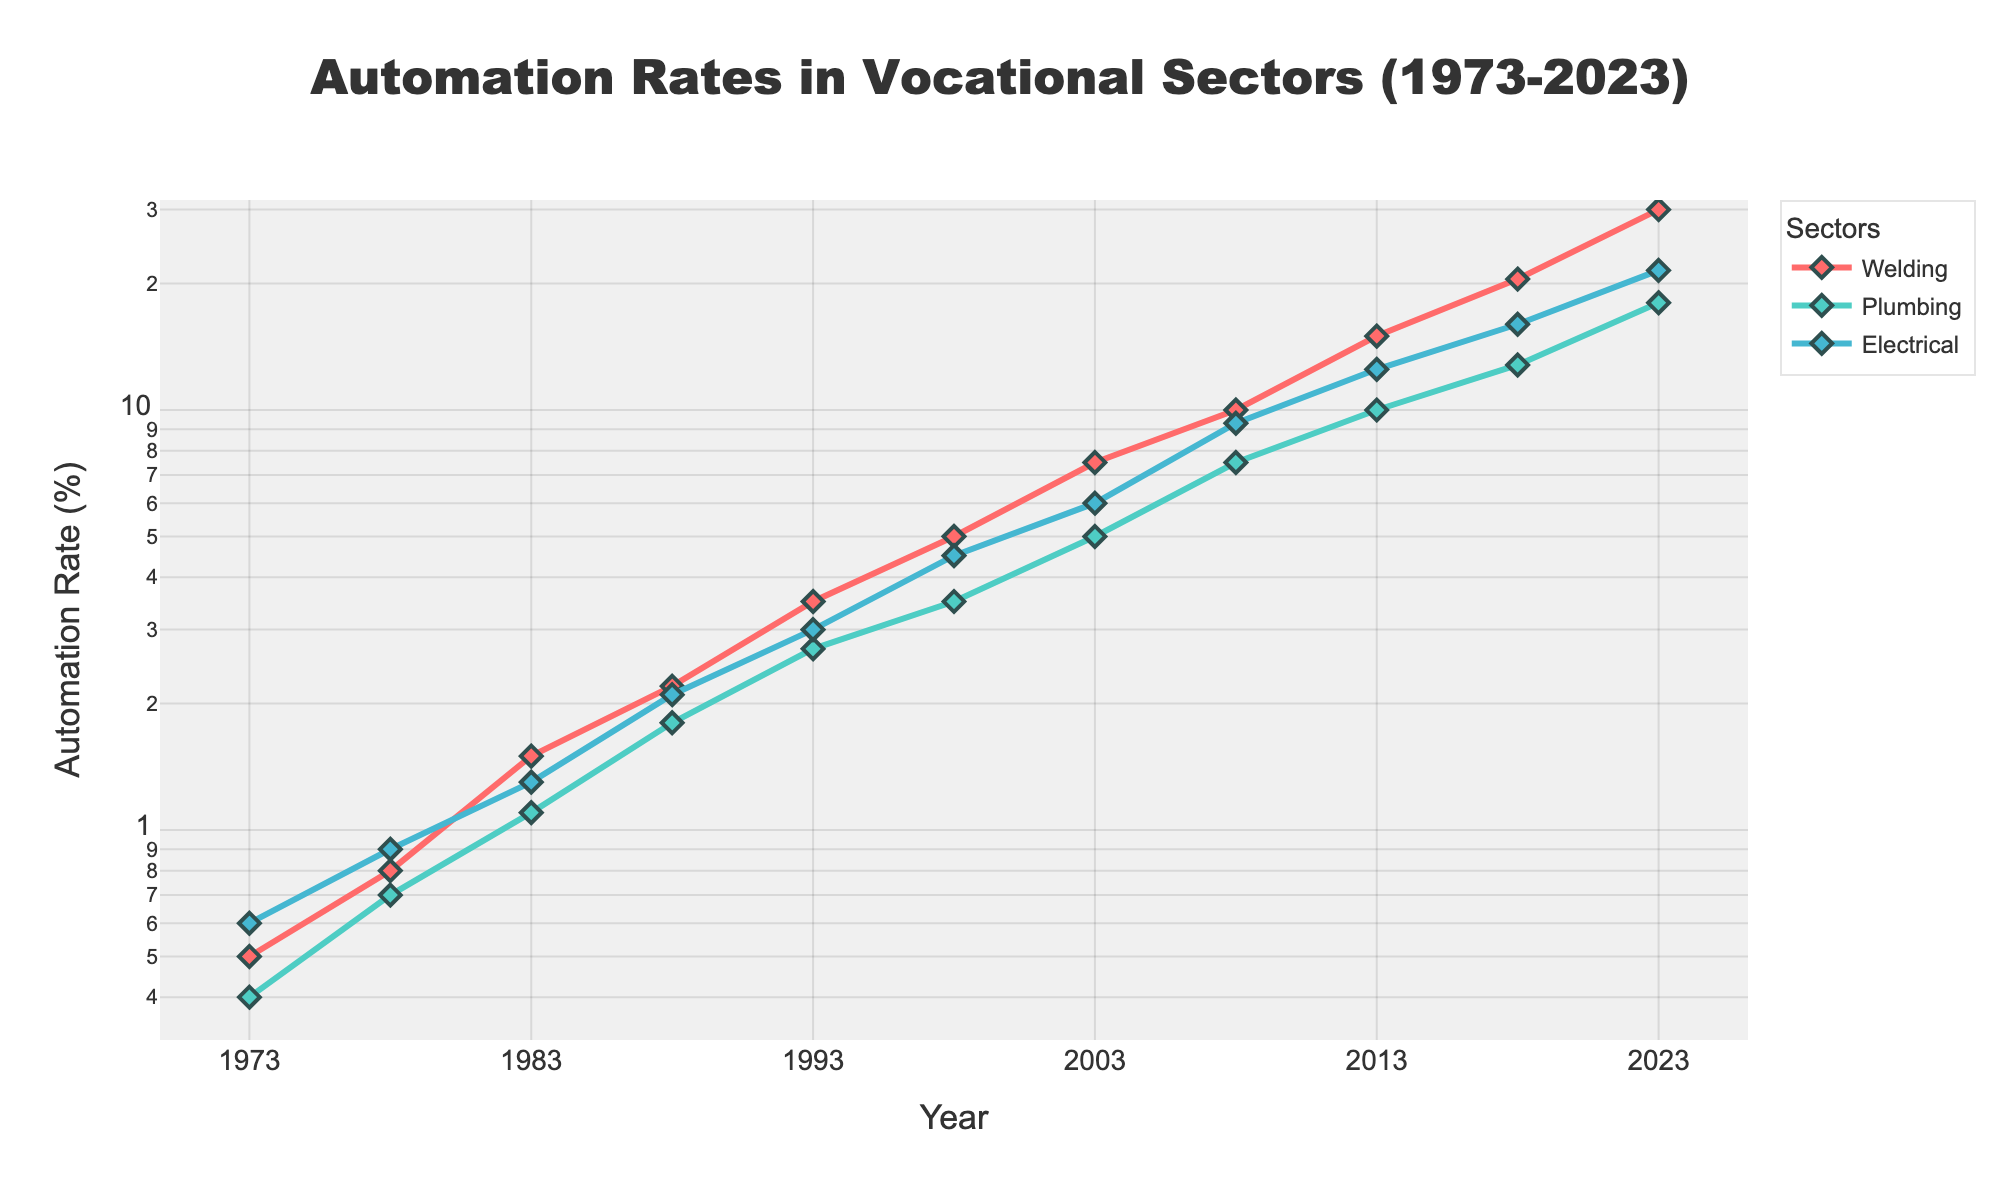What is the title of the plot? The title of the plot is mentioned at the top of the figure and provides a summary of what the plot is about. The title is 'Automation Rates in Vocational Sectors (1973-2023)'.
Answer: Automation Rates in Vocational Sectors (1973-2023) How many data points are there for each vocational sector? Each vocational sector has one data point for each year listed. Given the years range from 1973 to 2023 in increments of 5 years, there are 11 data points for each sector.
Answer: 11 Which sector had the highest automation rate in 2008? To find this, refer to the y-axis values for each sector in the year 2008. Welding had a rate of 10.0%, plumbing had 7.5%, and electrical had 9.3%. Welding has the highest rate.
Answer: Welding Did any sector exhibit a consistent increase in automation rate over the 50 years? By observing the trend lines for each sector, we can see that all sectors (welding, plumbing, and electrical) show a consistent increase in their automation rates over the years.
Answer: Yes Which sector's automation rate experienced the greatest increase from 1973 to 2023? To determine this, calculate the difference in automation rates between 1973 and 2023 for each sector. Welding increased from 0.5% to 30.0% (29.5%), plumbing from 0.4% to 18.0% (17.6%), and electrical from 0.6% to 21.5% (20.9%). Welding saw the greatest increase.
Answer: Welding What is the automation rate for plumbing in 1998? Locate the year 1998 on the x-axis, then find the corresponding point on the plumbing line (green). The automation rate for plumbing in 1998 is 3.5%.
Answer: 3.5% Between which consecutive years did the welding sector see the largest jump in automation rate? By how much? Observe the welding line (red) and calculate the differences in automation rates between consecutive years. The largest jump is between 2018 and 2023, from 20.5% to 30.0%, a difference of 9.5%.
Answer: 2018-2023, 9.5% Which year did the electrical sector surpass a 10% automation rate? Find the electrical sector line (blue), and note the year it first crosses the 10% mark on the y-axis. This occurs at 2013.
Answer: 2013 What is the overall trend in automation rates in vocational sectors over the observed period? All three sectors (welding, plumbing, and electrical) show a clearly increasing trend in their automation rates over the period from 1973 to 2023.
Answer: Increasing Which sector has the least variation in its automation rate increases? Examine the lines' smoothness and slopes for each sector. The plumbing sector (green) has relatively smoother, more consistent rate changes compared to the steeper increases in welding and electrical.
Answer: Plumbing 